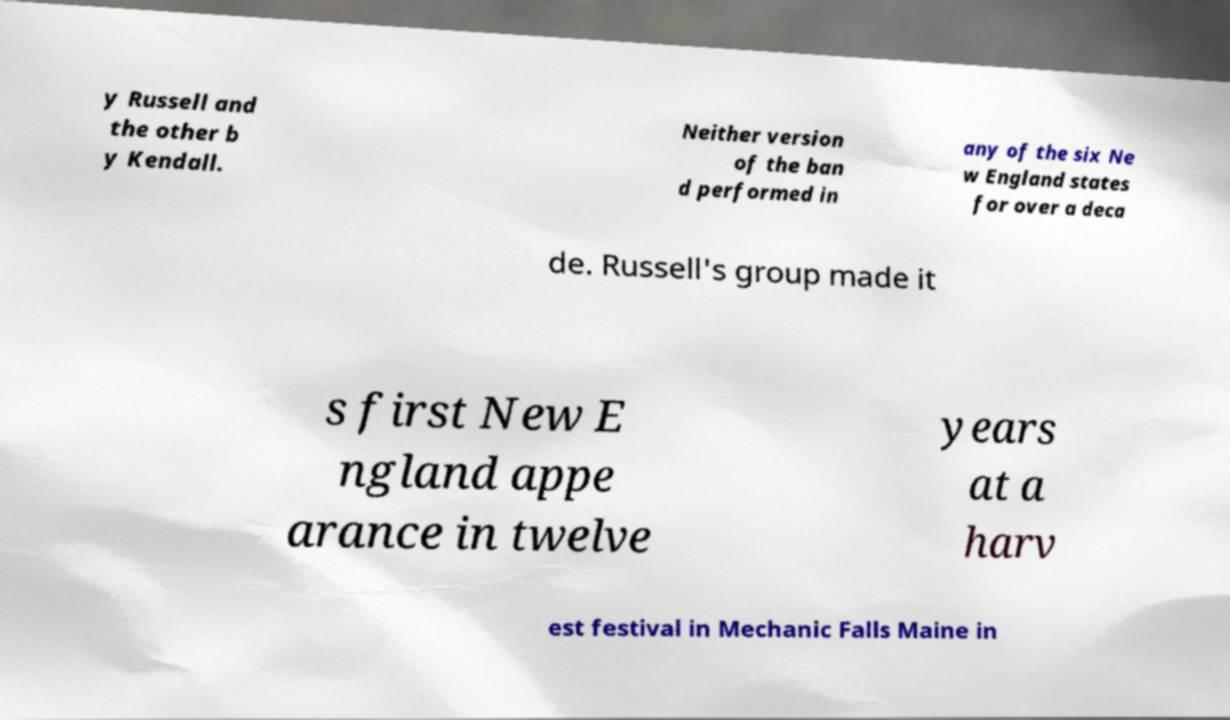Can you accurately transcribe the text from the provided image for me? y Russell and the other b y Kendall. Neither version of the ban d performed in any of the six Ne w England states for over a deca de. Russell's group made it s first New E ngland appe arance in twelve years at a harv est festival in Mechanic Falls Maine in 